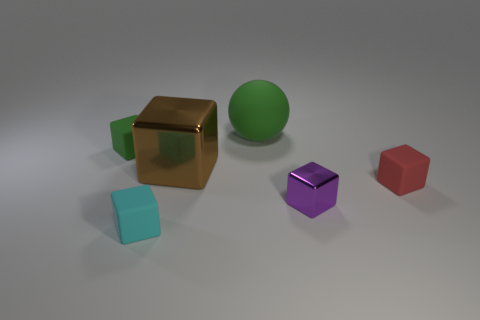Subtract all big brown shiny cubes. How many cubes are left? 4 Subtract all cyan cubes. How many cubes are left? 4 Subtract all gray blocks. Subtract all blue spheres. How many blocks are left? 5 Add 1 red balls. How many objects exist? 7 Subtract all balls. How many objects are left? 5 Add 2 big red metal spheres. How many big red metal spheres exist? 2 Subtract 0 purple spheres. How many objects are left? 6 Subtract all green matte things. Subtract all small green blocks. How many objects are left? 3 Add 2 tiny green matte cubes. How many tiny green matte cubes are left? 3 